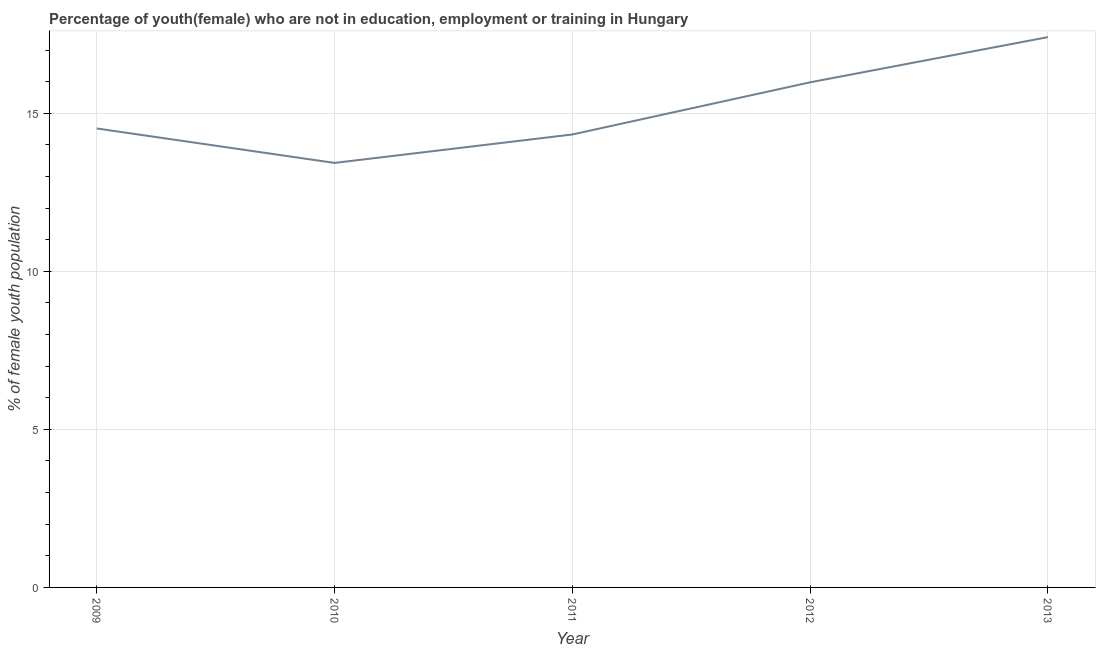What is the unemployed female youth population in 2013?
Offer a very short reply. 17.41. Across all years, what is the maximum unemployed female youth population?
Ensure brevity in your answer.  17.41. Across all years, what is the minimum unemployed female youth population?
Ensure brevity in your answer.  13.43. What is the sum of the unemployed female youth population?
Provide a succinct answer. 75.67. What is the difference between the unemployed female youth population in 2009 and 2013?
Your answer should be very brief. -2.89. What is the average unemployed female youth population per year?
Give a very brief answer. 15.13. What is the median unemployed female youth population?
Your response must be concise. 14.52. Do a majority of the years between 2010 and 2012 (inclusive) have unemployed female youth population greater than 15 %?
Give a very brief answer. No. What is the ratio of the unemployed female youth population in 2010 to that in 2013?
Your response must be concise. 0.77. Is the unemployed female youth population in 2010 less than that in 2012?
Make the answer very short. Yes. Is the difference between the unemployed female youth population in 2012 and 2013 greater than the difference between any two years?
Make the answer very short. No. What is the difference between the highest and the second highest unemployed female youth population?
Offer a very short reply. 1.43. What is the difference between the highest and the lowest unemployed female youth population?
Keep it short and to the point. 3.98. Does the unemployed female youth population monotonically increase over the years?
Keep it short and to the point. No. How many years are there in the graph?
Ensure brevity in your answer.  5. What is the title of the graph?
Your response must be concise. Percentage of youth(female) who are not in education, employment or training in Hungary. What is the label or title of the Y-axis?
Ensure brevity in your answer.  % of female youth population. What is the % of female youth population in 2009?
Keep it short and to the point. 14.52. What is the % of female youth population of 2010?
Provide a succinct answer. 13.43. What is the % of female youth population of 2011?
Give a very brief answer. 14.33. What is the % of female youth population in 2012?
Keep it short and to the point. 15.98. What is the % of female youth population of 2013?
Keep it short and to the point. 17.41. What is the difference between the % of female youth population in 2009 and 2010?
Provide a short and direct response. 1.09. What is the difference between the % of female youth population in 2009 and 2011?
Keep it short and to the point. 0.19. What is the difference between the % of female youth population in 2009 and 2012?
Provide a short and direct response. -1.46. What is the difference between the % of female youth population in 2009 and 2013?
Make the answer very short. -2.89. What is the difference between the % of female youth population in 2010 and 2012?
Your response must be concise. -2.55. What is the difference between the % of female youth population in 2010 and 2013?
Make the answer very short. -3.98. What is the difference between the % of female youth population in 2011 and 2012?
Your answer should be compact. -1.65. What is the difference between the % of female youth population in 2011 and 2013?
Your answer should be very brief. -3.08. What is the difference between the % of female youth population in 2012 and 2013?
Keep it short and to the point. -1.43. What is the ratio of the % of female youth population in 2009 to that in 2010?
Offer a very short reply. 1.08. What is the ratio of the % of female youth population in 2009 to that in 2011?
Your response must be concise. 1.01. What is the ratio of the % of female youth population in 2009 to that in 2012?
Provide a succinct answer. 0.91. What is the ratio of the % of female youth population in 2009 to that in 2013?
Provide a succinct answer. 0.83. What is the ratio of the % of female youth population in 2010 to that in 2011?
Your answer should be compact. 0.94. What is the ratio of the % of female youth population in 2010 to that in 2012?
Keep it short and to the point. 0.84. What is the ratio of the % of female youth population in 2010 to that in 2013?
Offer a terse response. 0.77. What is the ratio of the % of female youth population in 2011 to that in 2012?
Give a very brief answer. 0.9. What is the ratio of the % of female youth population in 2011 to that in 2013?
Ensure brevity in your answer.  0.82. What is the ratio of the % of female youth population in 2012 to that in 2013?
Your answer should be very brief. 0.92. 